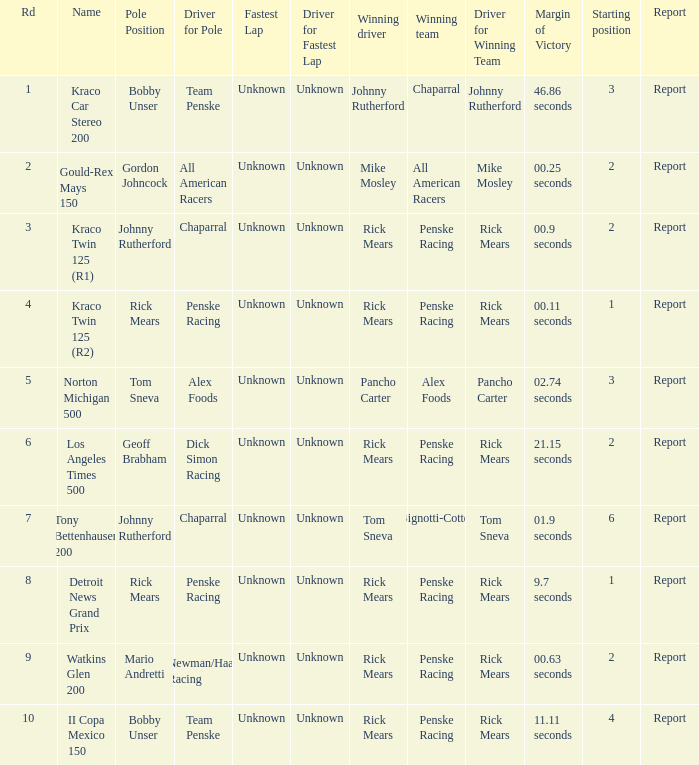How many winning drivers in the kraco twin 125 (r2) race were there? 1.0. Can you give me this table as a dict? {'header': ['Rd', 'Name', 'Pole Position', 'Driver for Pole', 'Fastest Lap', 'Driver for Fastest Lap', 'Winning driver', 'Winning team', 'Driver for Winning Team', 'Margin of Victory', 'Starting position', 'Report'], 'rows': [['1', 'Kraco Car Stereo 200', 'Bobby Unser', 'Team Penske', 'Unknown', 'Unknown', 'Johnny Rutherford', 'Chaparral', 'Johnny Rutherford', '46.86 seconds', '3', 'Report'], ['2', 'Gould-Rex Mays 150', 'Gordon Johncock', 'All American Racers', 'Unknown', 'Unknown', 'Mike Mosley', 'All American Racers', 'Mike Mosley', '00.25 seconds', '2', 'Report'], ['3', 'Kraco Twin 125 (R1)', 'Johnny Rutherford', 'Chaparral', 'Unknown', 'Unknown', 'Rick Mears', 'Penske Racing', 'Rick Mears', '00.9 seconds', '2', 'Report'], ['4', 'Kraco Twin 125 (R2)', 'Rick Mears', 'Penske Racing', 'Unknown', 'Unknown', 'Rick Mears', 'Penske Racing', 'Rick Mears', '00.11 seconds', '1', 'Report'], ['5', 'Norton Michigan 500', 'Tom Sneva', 'Alex Foods', 'Unknown', 'Unknown', 'Pancho Carter', 'Alex Foods', 'Pancho Carter', '02.74 seconds', '3', 'Report'], ['6', 'Los Angeles Times 500', 'Geoff Brabham', 'Dick Simon Racing', 'Unknown', 'Unknown', 'Rick Mears', 'Penske Racing', 'Rick Mears', '21.15 seconds', '2', 'Report'], ['7', 'Tony Bettenhausen 200', 'Johnny Rutherford', 'Chaparral', 'Unknown', 'Unknown', 'Tom Sneva', 'Bignotti-Cotter', 'Tom Sneva', '01.9 seconds', '6', 'Report'], ['8', 'Detroit News Grand Prix', 'Rick Mears', 'Penske Racing', 'Unknown', 'Unknown', 'Rick Mears', 'Penske Racing', 'Rick Mears', '9.7 seconds', '1', 'Report'], ['9', 'Watkins Glen 200', 'Mario Andretti', 'Newman/Haas Racing', 'Unknown', 'Unknown', 'Rick Mears', 'Penske Racing', 'Rick Mears', '00.63 seconds', '2', 'Report'], ['10', 'II Copa Mexico 150', 'Bobby Unser', 'Team Penske', 'Unknown', 'Unknown', 'Rick Mears', 'Penske Racing', 'Rick Mears', '11.11 seconds', '4', 'Report']]} 